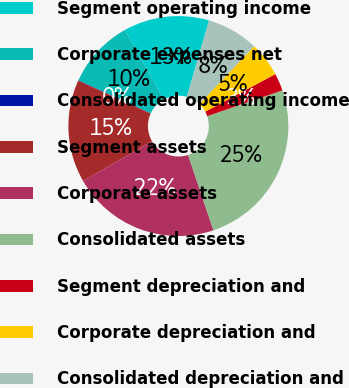Convert chart to OTSL. <chart><loc_0><loc_0><loc_500><loc_500><pie_chart><fcel>Segment operating income<fcel>Corporate expenses net<fcel>Consolidated operating income<fcel>Segment assets<fcel>Corporate assets<fcel>Consolidated assets<fcel>Segment depreciation and<fcel>Corporate depreciation and<fcel>Consolidated depreciation and<nl><fcel>12.59%<fcel>10.08%<fcel>0.07%<fcel>15.09%<fcel>21.84%<fcel>25.1%<fcel>2.57%<fcel>5.08%<fcel>7.58%<nl></chart> 